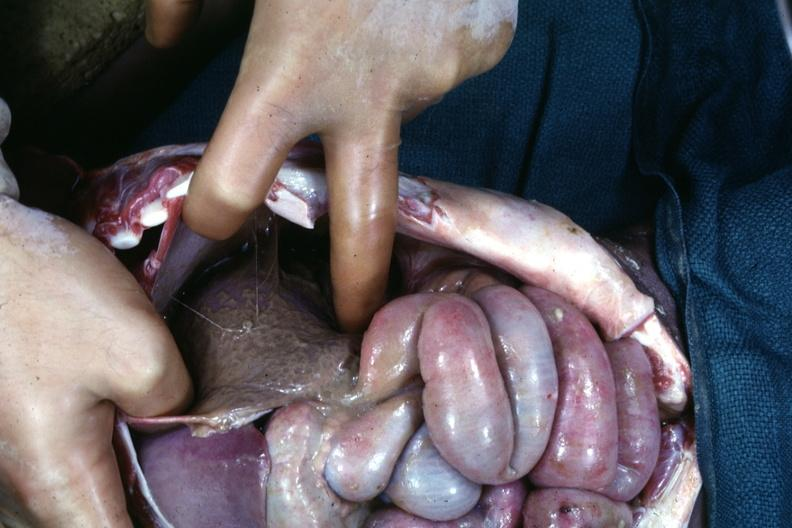what see other slides?
Answer the question using a single word or phrase. An opened peritoneal cavity cause by fibrous band strangulation 